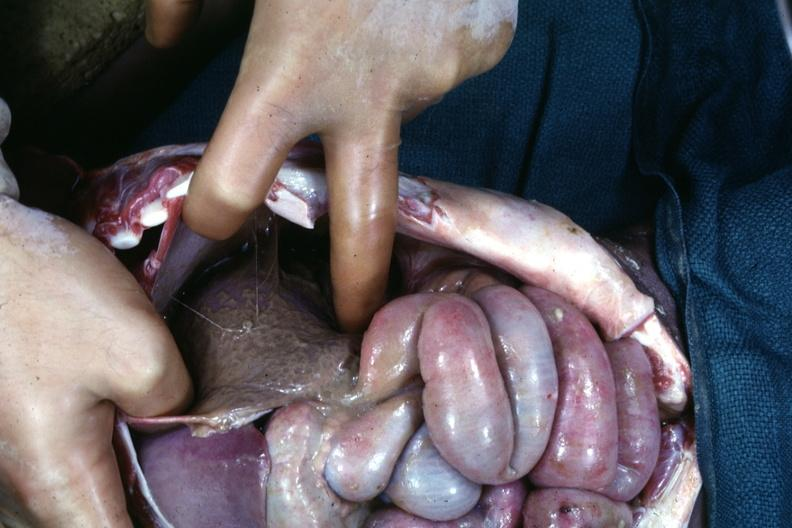what see other slides?
Answer the question using a single word or phrase. An opened peritoneal cavity cause by fibrous band strangulation 